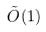<formula> <loc_0><loc_0><loc_500><loc_500>\tilde { O } ( 1 )</formula> 